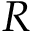Convert formula to latex. <formula><loc_0><loc_0><loc_500><loc_500>R</formula> 